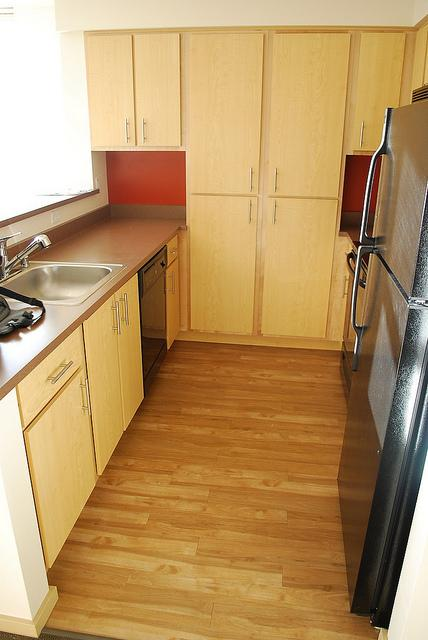What is going on with this room? Please explain your reasoning. no occupant. There is no cooking. 